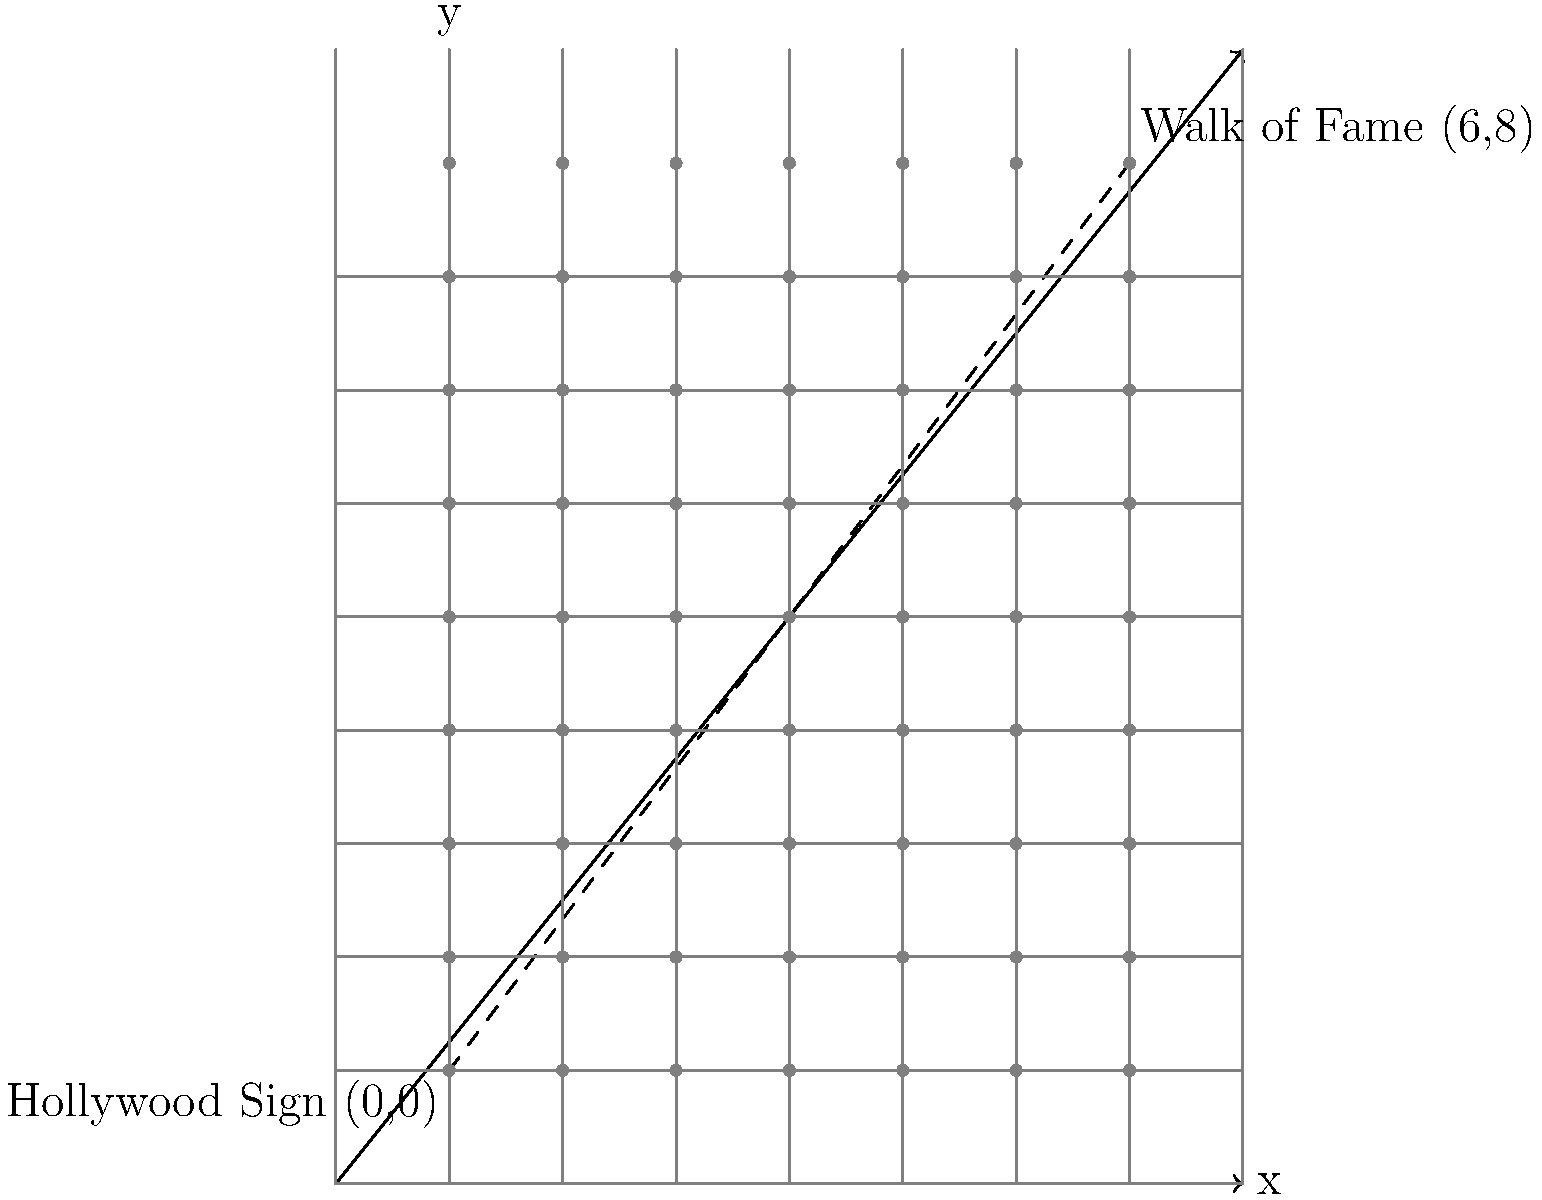As a literary agent excited about your historian's upcoming book on the golden age of Hollywood, you want to verify some geographical details. The historian mentions that the Hollywood Sign and the Walk of Fame can be represented on a coordinate plane, with the Hollywood Sign at (0,0) and the Walk of Fame at (6,8). Using the distance formula, calculate the straight-line distance between these two famous landmarks. Round your answer to the nearest tenth of a mile, assuming each unit on the coordinate plane represents one mile. To solve this problem, we'll use the distance formula derived from the Pythagorean theorem:

1) The distance formula is: 
   $$d = \sqrt{(x_2-x_1)^2 + (y_2-y_1)^2}$$

2) We have two points:
   Hollywood Sign: $(x_1,y_1) = (0,0)$
   Walk of Fame: $(x_2,y_2) = (6,8)$

3) Let's substitute these values into the formula:
   $$d = \sqrt{(6-0)^2 + (8-0)^2}$$

4) Simplify inside the parentheses:
   $$d = \sqrt{6^2 + 8^2}$$

5) Calculate the squares:
   $$d = \sqrt{36 + 64}$$

6) Add inside the square root:
   $$d = \sqrt{100}$$

7) Calculate the square root:
   $$d = 10$$

8) Since each unit represents one mile, the distance is 10 miles.

9) The question asks for the answer rounded to the nearest tenth, but 10 is already a whole number, so no further rounding is necessary.

Therefore, the straight-line distance between the Hollywood Sign and the Walk of Fame is 10 miles.
Answer: 10 miles 